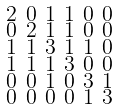<formula> <loc_0><loc_0><loc_500><loc_500>\begin{smallmatrix} 2 & 0 & 1 & 1 & 0 & 0 \\ 0 & 2 & 1 & 1 & 0 & 0 \\ 1 & 1 & 3 & 1 & 1 & 0 \\ 1 & 1 & 1 & 3 & 0 & 0 \\ 0 & 0 & 1 & 0 & 3 & 1 \\ 0 & 0 & 0 & 0 & 1 & 3 \end{smallmatrix}</formula> 